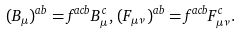Convert formula to latex. <formula><loc_0><loc_0><loc_500><loc_500>( B _ { \mu } ) ^ { a b } = f ^ { a c b } B _ { \mu } ^ { \, c } , \, ( F _ { \mu \nu } ) ^ { a b } = f ^ { a c b } F _ { \mu \nu } ^ { \, c } .</formula> 